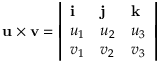Convert formula to latex. <formula><loc_0><loc_0><loc_500><loc_500>u \times v = { \left | \begin{array} { l l l } { i } & { j } & { k } \\ { u _ { 1 } } & { u _ { 2 } } & { u _ { 3 } } \\ { v _ { 1 } } & { v _ { 2 } } & { v _ { 3 } } \end{array} \right | }</formula> 